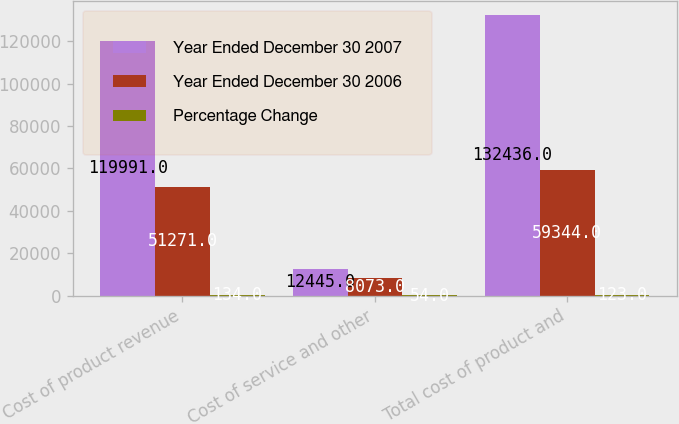<chart> <loc_0><loc_0><loc_500><loc_500><stacked_bar_chart><ecel><fcel>Cost of product revenue<fcel>Cost of service and other<fcel>Total cost of product and<nl><fcel>Year Ended December 30 2007<fcel>119991<fcel>12445<fcel>132436<nl><fcel>Year Ended December 30 2006<fcel>51271<fcel>8073<fcel>59344<nl><fcel>Percentage Change<fcel>134<fcel>54<fcel>123<nl></chart> 